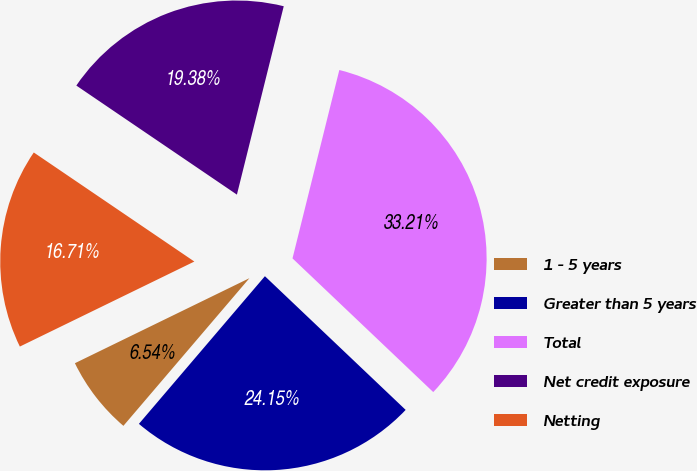Convert chart. <chart><loc_0><loc_0><loc_500><loc_500><pie_chart><fcel>1 - 5 years<fcel>Greater than 5 years<fcel>Total<fcel>Net credit exposure<fcel>Netting<nl><fcel>6.54%<fcel>24.15%<fcel>33.21%<fcel>19.38%<fcel>16.71%<nl></chart> 